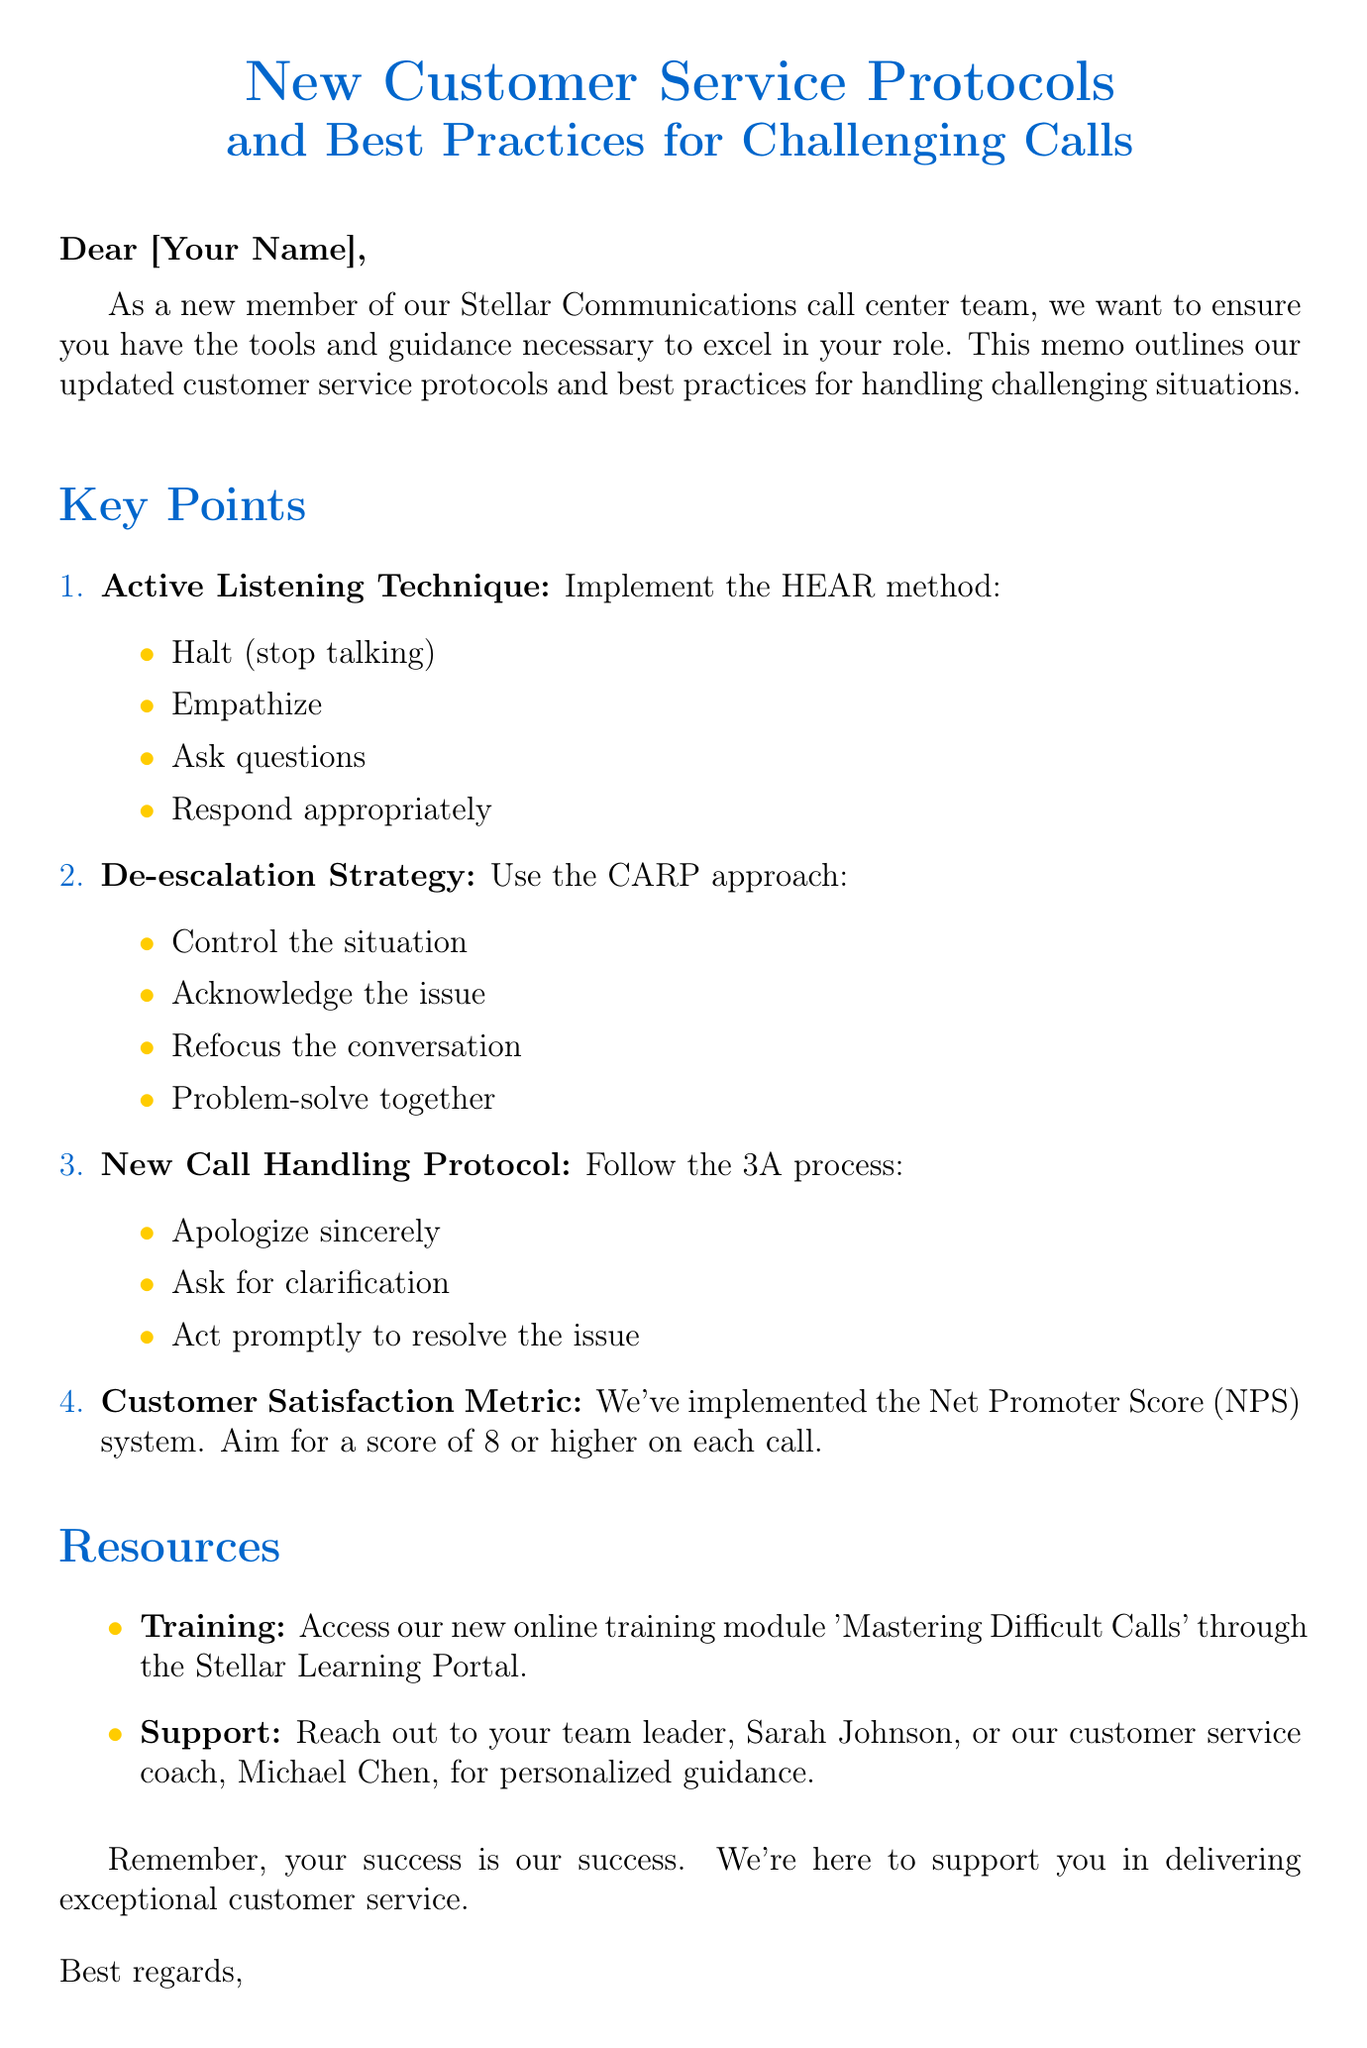what is the subject of the memo? The subject outlines the main topic of the document, focusing on new protocols and best practices.
Answer: New Customer Service Protocols and Best Practices for Challenging Calls who is the call center manager? This identifies the person responsible for the memo and support within the call center.
Answer: Emily Rodriguez what does the HEAR method stand for? The HEAR method is described as a technique for active listening, detailing specific actions to take.
Answer: Halt, Empathize, Ask questions, Respond appropriately what is the goal for the Net Promoter Score (NPS)? This refers to the customer satisfaction metric mentioned in the document, with a specific target score.
Answer: 8 or higher who can you reach out to for personalized guidance? This question seeks to identify the individuals listed in the document as available for support.
Answer: Sarah Johnson or Michael Chen what does the 3A process involve? This queries the key actions in the new call handling protocol discussed in the memo.
Answer: Apologize sincerely, Ask for clarification, Act promptly to resolve the issue what is the purpose of the online training module? This question relates to the provided resources for new call center employees.
Answer: Mastering Difficult Calls what is the key focus of the memo? This question aims to capture the overarching theme conveyed in the introduction of the document.
Answer: Updated customer service protocols and best practices for handling challenging situations 